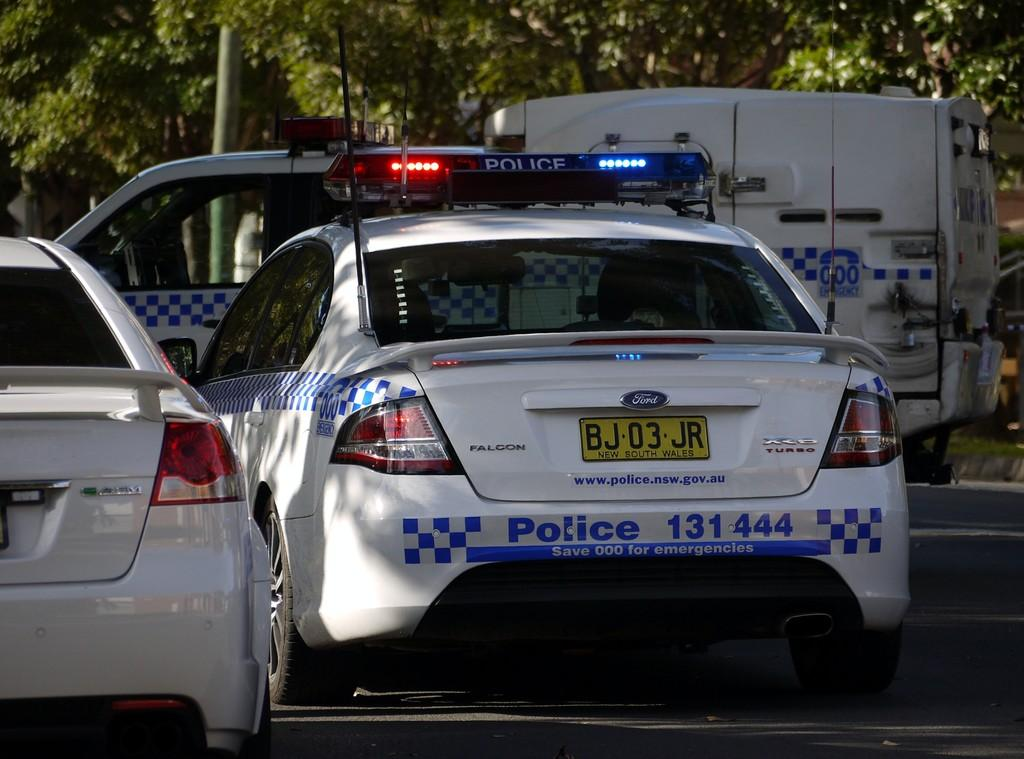What types of motor vehicles are in the image? The facts provided do not specify the types of motor vehicles in the image. Can you describe the background of the image? There are trees in the background of the image. What type of rice is being cooked in the image? There is no rice present in the image. How many clocks can be seen hanging on the trees in the image? There are no clocks visible in the image, as it features motor vehicles and trees in the background. What type of silk garment is being worn by the motor vehicles in the image? Motor vehicles do not wear garments, as they are inanimate objects. 